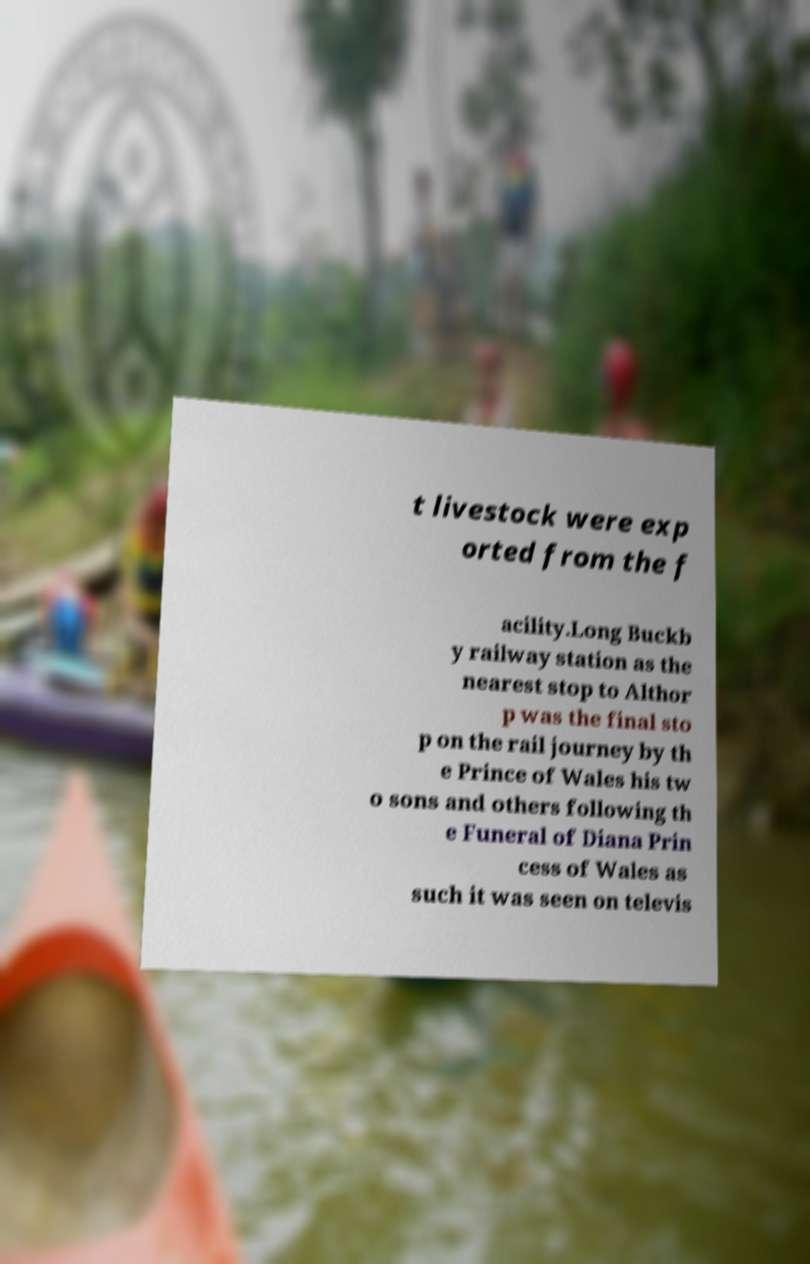Could you assist in decoding the text presented in this image and type it out clearly? t livestock were exp orted from the f acility.Long Buckb y railway station as the nearest stop to Althor p was the final sto p on the rail journey by th e Prince of Wales his tw o sons and others following th e Funeral of Diana Prin cess of Wales as such it was seen on televis 